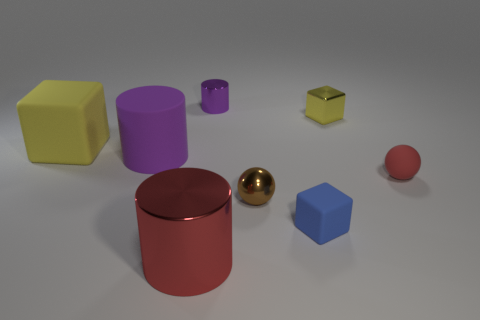Add 2 small red cylinders. How many objects exist? 10 Subtract all blocks. How many objects are left? 5 Add 6 green blocks. How many green blocks exist? 6 Subtract 0 brown cylinders. How many objects are left? 8 Subtract all large balls. Subtract all large red metal objects. How many objects are left? 7 Add 8 large shiny cylinders. How many large shiny cylinders are left? 9 